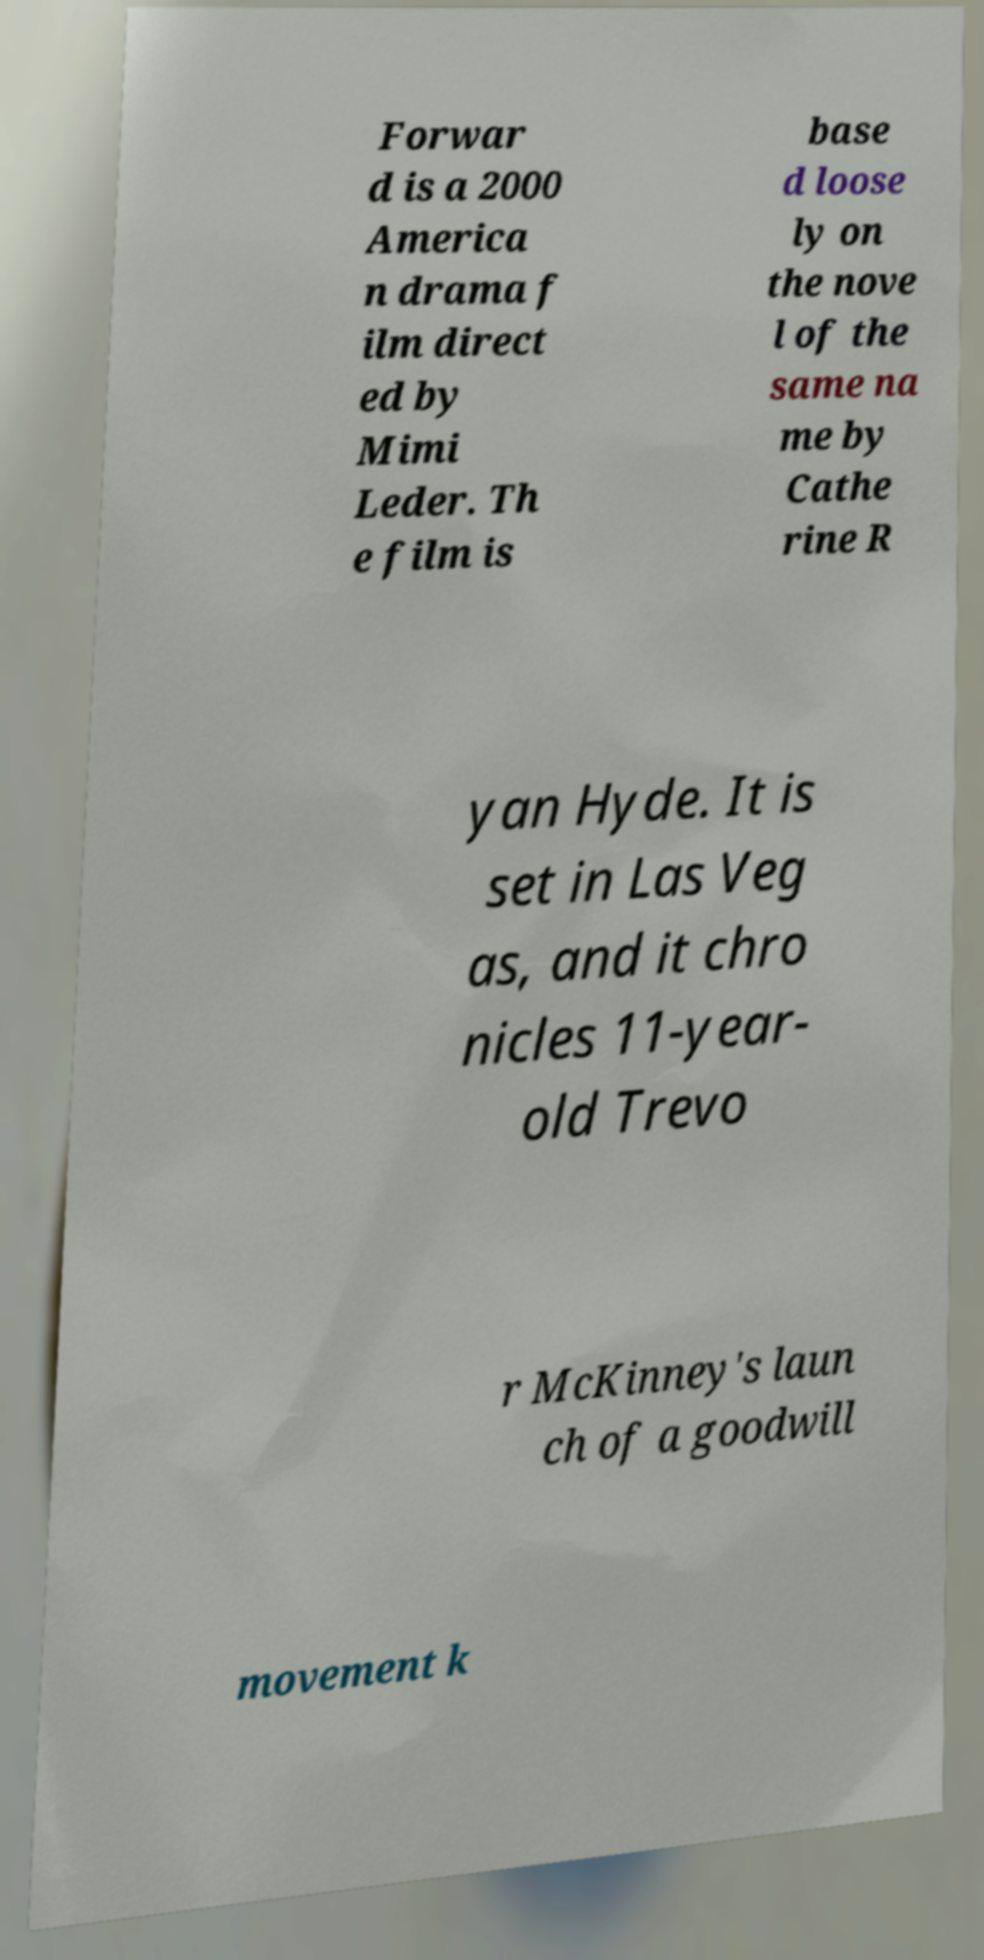Can you read and provide the text displayed in the image?This photo seems to have some interesting text. Can you extract and type it out for me? Forwar d is a 2000 America n drama f ilm direct ed by Mimi Leder. Th e film is base d loose ly on the nove l of the same na me by Cathe rine R yan Hyde. It is set in Las Veg as, and it chro nicles 11-year- old Trevo r McKinney's laun ch of a goodwill movement k 